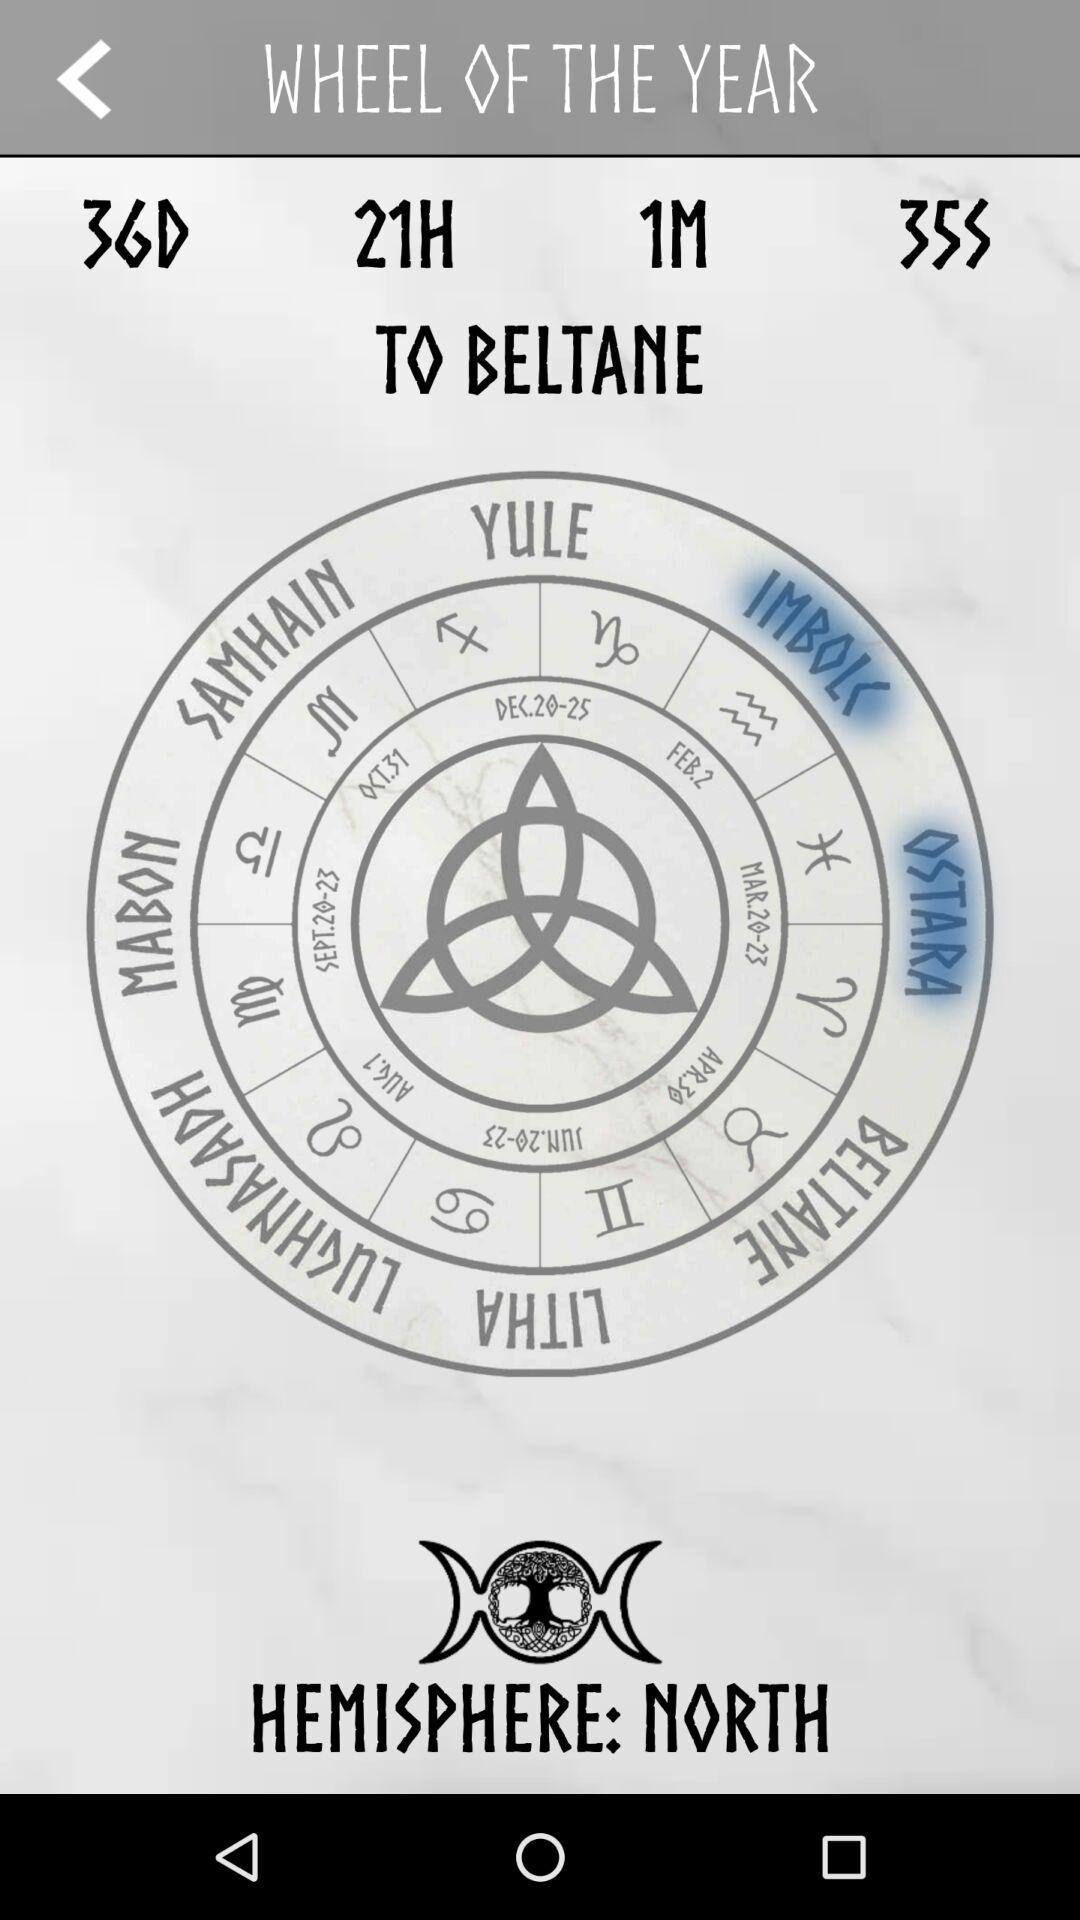What is the hemisphere? The hemisphere is "NORTH". 